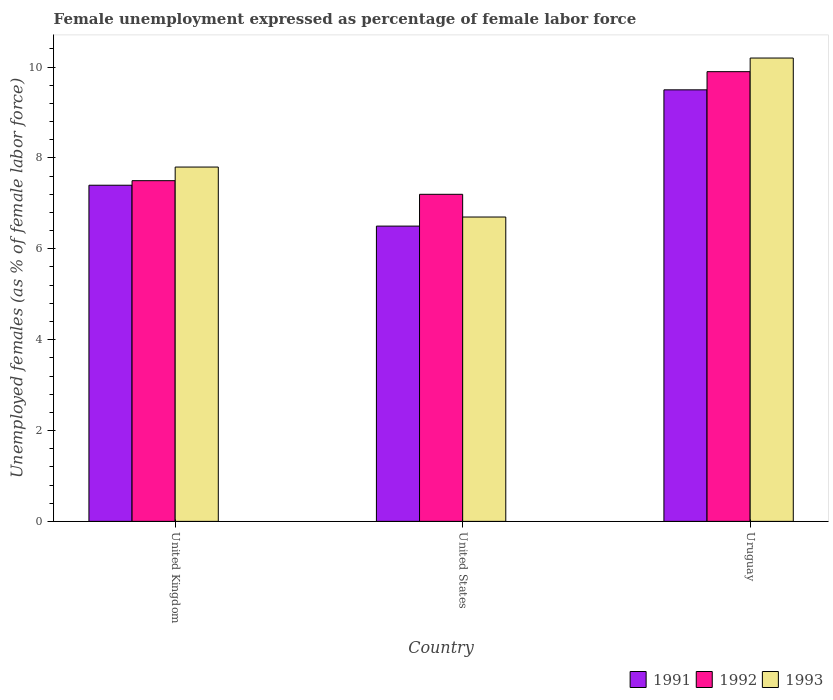How many different coloured bars are there?
Provide a short and direct response. 3. How many groups of bars are there?
Your answer should be compact. 3. Are the number of bars on each tick of the X-axis equal?
Your answer should be very brief. Yes. What is the label of the 3rd group of bars from the left?
Provide a succinct answer. Uruguay. In how many cases, is the number of bars for a given country not equal to the number of legend labels?
Keep it short and to the point. 0. What is the unemployment in females in in 1991 in United States?
Offer a very short reply. 6.5. Across all countries, what is the maximum unemployment in females in in 1991?
Offer a terse response. 9.5. Across all countries, what is the minimum unemployment in females in in 1992?
Give a very brief answer. 7.2. In which country was the unemployment in females in in 1993 maximum?
Make the answer very short. Uruguay. What is the total unemployment in females in in 1991 in the graph?
Give a very brief answer. 23.4. What is the difference between the unemployment in females in in 1991 in United Kingdom and that in Uruguay?
Provide a short and direct response. -2.1. What is the difference between the unemployment in females in in 1993 in United States and the unemployment in females in in 1992 in United Kingdom?
Your response must be concise. -0.8. What is the average unemployment in females in in 1991 per country?
Offer a very short reply. 7.8. What is the difference between the unemployment in females in of/in 1992 and unemployment in females in of/in 1991 in United Kingdom?
Your response must be concise. 0.1. What is the ratio of the unemployment in females in in 1992 in United Kingdom to that in United States?
Keep it short and to the point. 1.04. Is the difference between the unemployment in females in in 1992 in United Kingdom and Uruguay greater than the difference between the unemployment in females in in 1991 in United Kingdom and Uruguay?
Ensure brevity in your answer.  No. What is the difference between the highest and the second highest unemployment in females in in 1993?
Provide a short and direct response. 3.5. What does the 1st bar from the left in United Kingdom represents?
Your answer should be very brief. 1991. What does the 1st bar from the right in United Kingdom represents?
Your answer should be compact. 1993. Are all the bars in the graph horizontal?
Keep it short and to the point. No. Are the values on the major ticks of Y-axis written in scientific E-notation?
Make the answer very short. No. Where does the legend appear in the graph?
Your response must be concise. Bottom right. How are the legend labels stacked?
Your answer should be compact. Horizontal. What is the title of the graph?
Your answer should be very brief. Female unemployment expressed as percentage of female labor force. What is the label or title of the X-axis?
Give a very brief answer. Country. What is the label or title of the Y-axis?
Ensure brevity in your answer.  Unemployed females (as % of female labor force). What is the Unemployed females (as % of female labor force) of 1991 in United Kingdom?
Provide a succinct answer. 7.4. What is the Unemployed females (as % of female labor force) of 1992 in United Kingdom?
Offer a terse response. 7.5. What is the Unemployed females (as % of female labor force) in 1993 in United Kingdom?
Your answer should be very brief. 7.8. What is the Unemployed females (as % of female labor force) of 1991 in United States?
Ensure brevity in your answer.  6.5. What is the Unemployed females (as % of female labor force) of 1992 in United States?
Keep it short and to the point. 7.2. What is the Unemployed females (as % of female labor force) in 1993 in United States?
Your answer should be very brief. 6.7. What is the Unemployed females (as % of female labor force) of 1992 in Uruguay?
Your answer should be compact. 9.9. What is the Unemployed females (as % of female labor force) in 1993 in Uruguay?
Ensure brevity in your answer.  10.2. Across all countries, what is the maximum Unemployed females (as % of female labor force) of 1992?
Keep it short and to the point. 9.9. Across all countries, what is the maximum Unemployed females (as % of female labor force) in 1993?
Provide a short and direct response. 10.2. Across all countries, what is the minimum Unemployed females (as % of female labor force) of 1991?
Give a very brief answer. 6.5. Across all countries, what is the minimum Unemployed females (as % of female labor force) in 1992?
Provide a succinct answer. 7.2. Across all countries, what is the minimum Unemployed females (as % of female labor force) in 1993?
Provide a succinct answer. 6.7. What is the total Unemployed females (as % of female labor force) of 1991 in the graph?
Offer a terse response. 23.4. What is the total Unemployed females (as % of female labor force) in 1992 in the graph?
Your answer should be very brief. 24.6. What is the total Unemployed females (as % of female labor force) of 1993 in the graph?
Ensure brevity in your answer.  24.7. What is the difference between the Unemployed females (as % of female labor force) of 1991 in United Kingdom and that in United States?
Your response must be concise. 0.9. What is the difference between the Unemployed females (as % of female labor force) of 1993 in United Kingdom and that in United States?
Keep it short and to the point. 1.1. What is the difference between the Unemployed females (as % of female labor force) in 1991 in United Kingdom and that in Uruguay?
Provide a succinct answer. -2.1. What is the difference between the Unemployed females (as % of female labor force) in 1992 in United States and that in Uruguay?
Offer a very short reply. -2.7. What is the difference between the Unemployed females (as % of female labor force) in 1993 in United States and that in Uruguay?
Give a very brief answer. -3.5. What is the difference between the Unemployed females (as % of female labor force) in 1991 in United Kingdom and the Unemployed females (as % of female labor force) in 1993 in Uruguay?
Ensure brevity in your answer.  -2.8. What is the difference between the Unemployed females (as % of female labor force) in 1992 in United Kingdom and the Unemployed females (as % of female labor force) in 1993 in Uruguay?
Ensure brevity in your answer.  -2.7. What is the difference between the Unemployed females (as % of female labor force) in 1991 in United States and the Unemployed females (as % of female labor force) in 1992 in Uruguay?
Offer a terse response. -3.4. What is the difference between the Unemployed females (as % of female labor force) of 1991 in United States and the Unemployed females (as % of female labor force) of 1993 in Uruguay?
Provide a short and direct response. -3.7. What is the average Unemployed females (as % of female labor force) of 1992 per country?
Make the answer very short. 8.2. What is the average Unemployed females (as % of female labor force) in 1993 per country?
Provide a short and direct response. 8.23. What is the difference between the Unemployed females (as % of female labor force) in 1991 and Unemployed females (as % of female labor force) in 1992 in United Kingdom?
Offer a very short reply. -0.1. What is the difference between the Unemployed females (as % of female labor force) of 1991 and Unemployed females (as % of female labor force) of 1993 in United States?
Your answer should be compact. -0.2. What is the difference between the Unemployed females (as % of female labor force) in 1992 and Unemployed females (as % of female labor force) in 1993 in United States?
Provide a short and direct response. 0.5. What is the difference between the Unemployed females (as % of female labor force) of 1991 and Unemployed females (as % of female labor force) of 1992 in Uruguay?
Provide a succinct answer. -0.4. What is the ratio of the Unemployed females (as % of female labor force) in 1991 in United Kingdom to that in United States?
Keep it short and to the point. 1.14. What is the ratio of the Unemployed females (as % of female labor force) in 1992 in United Kingdom to that in United States?
Your response must be concise. 1.04. What is the ratio of the Unemployed females (as % of female labor force) of 1993 in United Kingdom to that in United States?
Offer a terse response. 1.16. What is the ratio of the Unemployed females (as % of female labor force) in 1991 in United Kingdom to that in Uruguay?
Your answer should be compact. 0.78. What is the ratio of the Unemployed females (as % of female labor force) in 1992 in United Kingdom to that in Uruguay?
Your answer should be compact. 0.76. What is the ratio of the Unemployed females (as % of female labor force) of 1993 in United Kingdom to that in Uruguay?
Provide a short and direct response. 0.76. What is the ratio of the Unemployed females (as % of female labor force) in 1991 in United States to that in Uruguay?
Provide a succinct answer. 0.68. What is the ratio of the Unemployed females (as % of female labor force) in 1992 in United States to that in Uruguay?
Provide a succinct answer. 0.73. What is the ratio of the Unemployed females (as % of female labor force) of 1993 in United States to that in Uruguay?
Keep it short and to the point. 0.66. What is the difference between the highest and the second highest Unemployed females (as % of female labor force) in 1991?
Your response must be concise. 2.1. What is the difference between the highest and the second highest Unemployed females (as % of female labor force) of 1992?
Give a very brief answer. 2.4. 